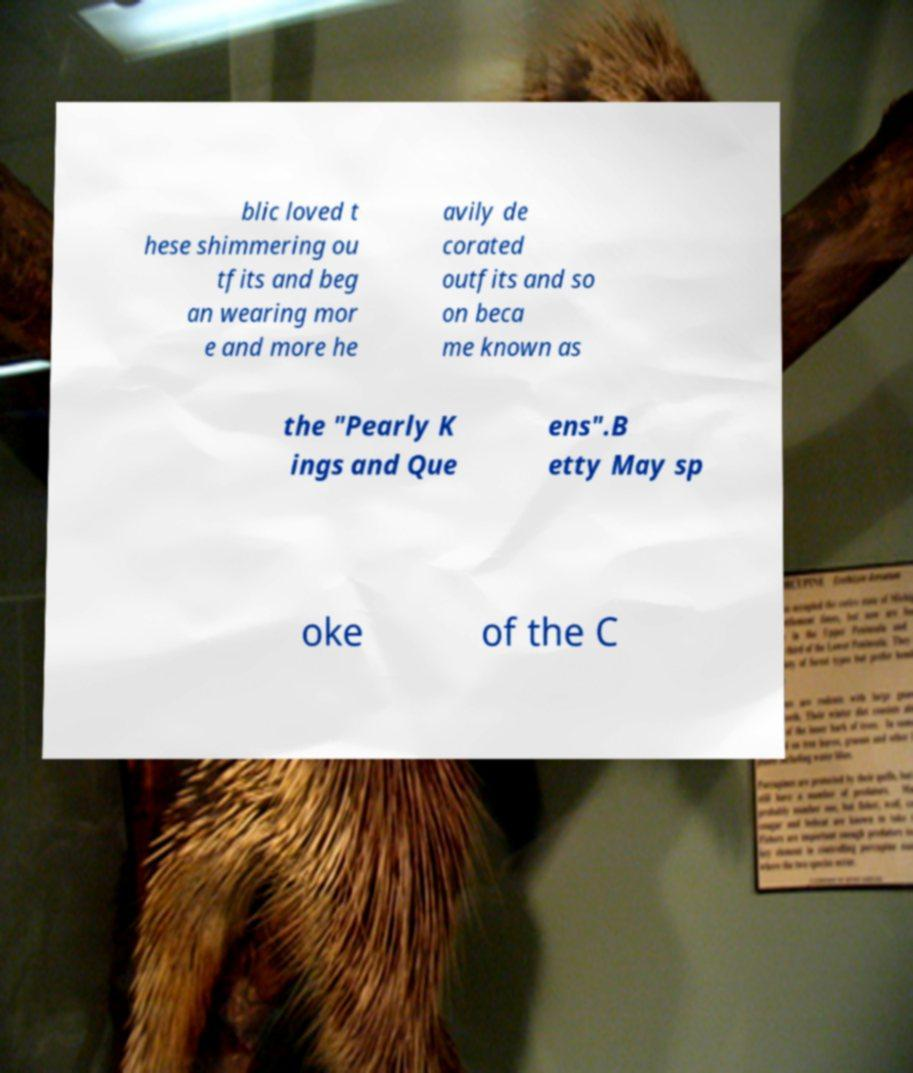What messages or text are displayed in this image? I need them in a readable, typed format. blic loved t hese shimmering ou tfits and beg an wearing mor e and more he avily de corated outfits and so on beca me known as the "Pearly K ings and Que ens".B etty May sp oke of the C 